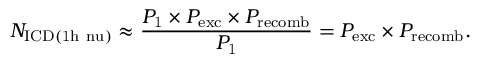Convert formula to latex. <formula><loc_0><loc_0><loc_500><loc_500>N _ { I C D ( 1 h \ n u ) } \approx \frac { P _ { 1 } \times P _ { e x c } \times P _ { r e c o m b } } { P _ { 1 } } = P _ { e x c } \times P _ { r e c o m b } .</formula> 